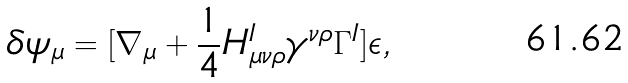<formula> <loc_0><loc_0><loc_500><loc_500>\delta \psi _ { \mu } = [ \nabla _ { \mu } + \frac { 1 } { 4 } H _ { \mu \nu \rho } ^ { I } \gamma ^ { \nu \rho } \Gamma ^ { I } ] \epsilon ,</formula> 